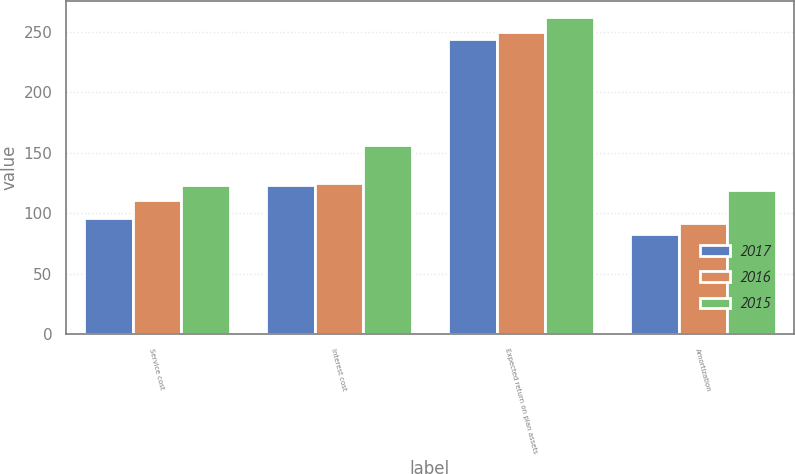Convert chart to OTSL. <chart><loc_0><loc_0><loc_500><loc_500><stacked_bar_chart><ecel><fcel>Service cost<fcel>Interest cost<fcel>Expected return on plan assets<fcel>Amortization<nl><fcel>2017<fcel>96<fcel>123<fcel>244<fcel>83<nl><fcel>2016<fcel>111<fcel>125<fcel>250<fcel>92<nl><fcel>2015<fcel>123<fcel>156<fcel>262<fcel>119<nl></chart> 